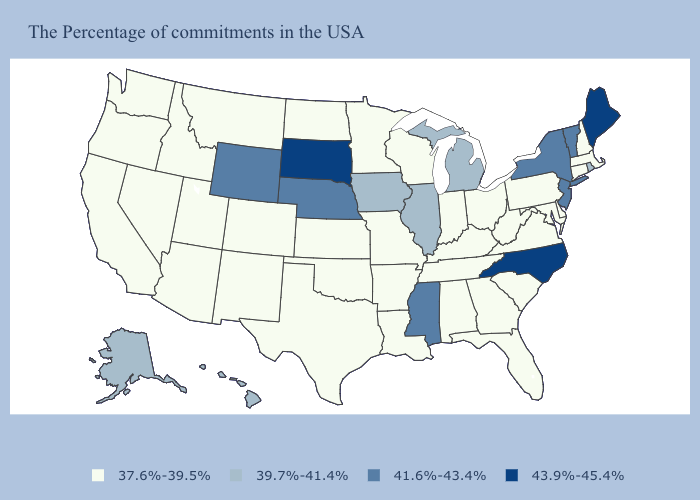Which states hav the highest value in the Northeast?
Write a very short answer. Maine. What is the lowest value in states that border Montana?
Keep it brief. 37.6%-39.5%. What is the value of Texas?
Be succinct. 37.6%-39.5%. Among the states that border Massachusetts , does Rhode Island have the lowest value?
Concise answer only. No. What is the highest value in the USA?
Short answer required. 43.9%-45.4%. Name the states that have a value in the range 37.6%-39.5%?
Concise answer only. Massachusetts, New Hampshire, Connecticut, Delaware, Maryland, Pennsylvania, Virginia, South Carolina, West Virginia, Ohio, Florida, Georgia, Kentucky, Indiana, Alabama, Tennessee, Wisconsin, Louisiana, Missouri, Arkansas, Minnesota, Kansas, Oklahoma, Texas, North Dakota, Colorado, New Mexico, Utah, Montana, Arizona, Idaho, Nevada, California, Washington, Oregon. Does the first symbol in the legend represent the smallest category?
Short answer required. Yes. Name the states that have a value in the range 41.6%-43.4%?
Give a very brief answer. Vermont, New York, New Jersey, Mississippi, Nebraska, Wyoming. Which states have the lowest value in the USA?
Short answer required. Massachusetts, New Hampshire, Connecticut, Delaware, Maryland, Pennsylvania, Virginia, South Carolina, West Virginia, Ohio, Florida, Georgia, Kentucky, Indiana, Alabama, Tennessee, Wisconsin, Louisiana, Missouri, Arkansas, Minnesota, Kansas, Oklahoma, Texas, North Dakota, Colorado, New Mexico, Utah, Montana, Arizona, Idaho, Nevada, California, Washington, Oregon. What is the highest value in the USA?
Quick response, please. 43.9%-45.4%. Name the states that have a value in the range 37.6%-39.5%?
Concise answer only. Massachusetts, New Hampshire, Connecticut, Delaware, Maryland, Pennsylvania, Virginia, South Carolina, West Virginia, Ohio, Florida, Georgia, Kentucky, Indiana, Alabama, Tennessee, Wisconsin, Louisiana, Missouri, Arkansas, Minnesota, Kansas, Oklahoma, Texas, North Dakota, Colorado, New Mexico, Utah, Montana, Arizona, Idaho, Nevada, California, Washington, Oregon. What is the value of Iowa?
Answer briefly. 39.7%-41.4%. Among the states that border Minnesota , does Iowa have the highest value?
Write a very short answer. No. Does North Carolina have the highest value in the USA?
Quick response, please. Yes. Does the first symbol in the legend represent the smallest category?
Short answer required. Yes. 